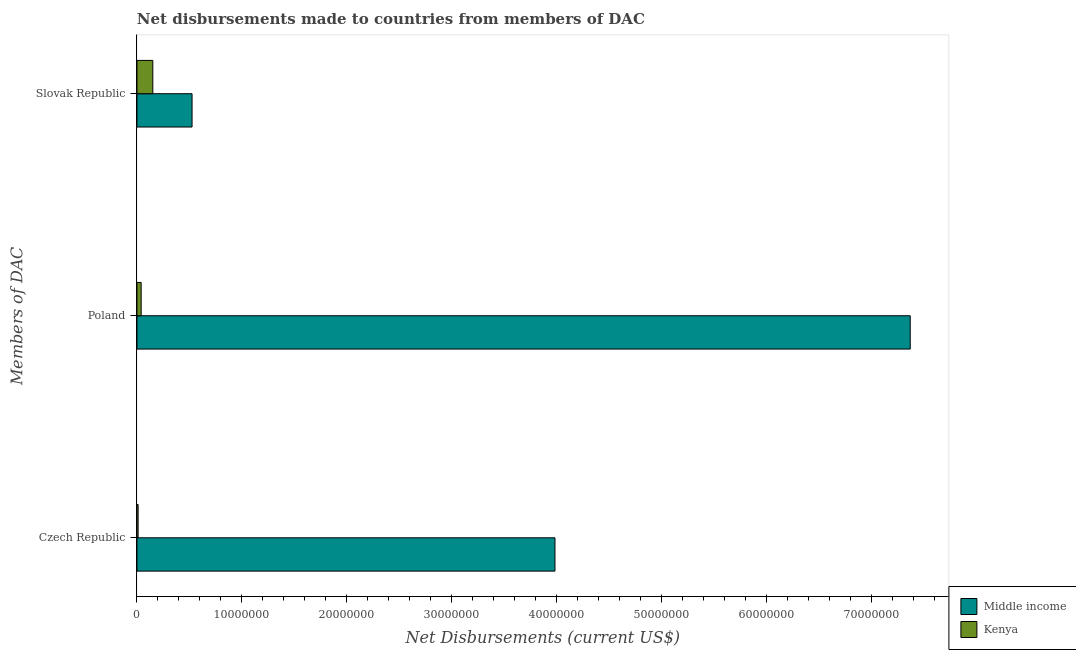Are the number of bars on each tick of the Y-axis equal?
Your answer should be compact. Yes. How many bars are there on the 2nd tick from the bottom?
Make the answer very short. 2. What is the net disbursements made by czech republic in Kenya?
Offer a terse response. 1.10e+05. Across all countries, what is the maximum net disbursements made by poland?
Your response must be concise. 7.37e+07. Across all countries, what is the minimum net disbursements made by slovak republic?
Provide a short and direct response. 1.51e+06. In which country was the net disbursements made by slovak republic minimum?
Offer a terse response. Kenya. What is the total net disbursements made by poland in the graph?
Your answer should be very brief. 7.41e+07. What is the difference between the net disbursements made by czech republic in Middle income and that in Kenya?
Keep it short and to the point. 3.97e+07. What is the difference between the net disbursements made by slovak republic in Middle income and the net disbursements made by czech republic in Kenya?
Make the answer very short. 5.14e+06. What is the average net disbursements made by czech republic per country?
Give a very brief answer. 2.00e+07. What is the difference between the net disbursements made by czech republic and net disbursements made by slovak republic in Middle income?
Offer a terse response. 3.46e+07. In how many countries, is the net disbursements made by poland greater than 30000000 US$?
Keep it short and to the point. 1. What is the ratio of the net disbursements made by poland in Middle income to that in Kenya?
Offer a terse response. 184.2. What is the difference between the highest and the second highest net disbursements made by poland?
Offer a terse response. 7.33e+07. What is the difference between the highest and the lowest net disbursements made by czech republic?
Ensure brevity in your answer.  3.97e+07. What does the 1st bar from the top in Poland represents?
Provide a succinct answer. Kenya. What does the 2nd bar from the bottom in Poland represents?
Your answer should be very brief. Kenya. How many bars are there?
Give a very brief answer. 6. Are all the bars in the graph horizontal?
Provide a short and direct response. Yes. How many countries are there in the graph?
Your response must be concise. 2. What is the difference between two consecutive major ticks on the X-axis?
Your response must be concise. 1.00e+07. Are the values on the major ticks of X-axis written in scientific E-notation?
Provide a short and direct response. No. Does the graph contain any zero values?
Ensure brevity in your answer.  No. Does the graph contain grids?
Make the answer very short. No. Where does the legend appear in the graph?
Ensure brevity in your answer.  Bottom right. What is the title of the graph?
Offer a terse response. Net disbursements made to countries from members of DAC. Does "Venezuela" appear as one of the legend labels in the graph?
Make the answer very short. No. What is the label or title of the X-axis?
Provide a short and direct response. Net Disbursements (current US$). What is the label or title of the Y-axis?
Make the answer very short. Members of DAC. What is the Net Disbursements (current US$) of Middle income in Czech Republic?
Your answer should be very brief. 3.98e+07. What is the Net Disbursements (current US$) in Middle income in Poland?
Your answer should be very brief. 7.37e+07. What is the Net Disbursements (current US$) of Kenya in Poland?
Make the answer very short. 4.00e+05. What is the Net Disbursements (current US$) of Middle income in Slovak Republic?
Make the answer very short. 5.25e+06. What is the Net Disbursements (current US$) of Kenya in Slovak Republic?
Keep it short and to the point. 1.51e+06. Across all Members of DAC, what is the maximum Net Disbursements (current US$) in Middle income?
Offer a terse response. 7.37e+07. Across all Members of DAC, what is the maximum Net Disbursements (current US$) of Kenya?
Your answer should be compact. 1.51e+06. Across all Members of DAC, what is the minimum Net Disbursements (current US$) of Middle income?
Your answer should be compact. 5.25e+06. Across all Members of DAC, what is the minimum Net Disbursements (current US$) in Kenya?
Ensure brevity in your answer.  1.10e+05. What is the total Net Disbursements (current US$) in Middle income in the graph?
Offer a terse response. 1.19e+08. What is the total Net Disbursements (current US$) in Kenya in the graph?
Provide a short and direct response. 2.02e+06. What is the difference between the Net Disbursements (current US$) in Middle income in Czech Republic and that in Poland?
Provide a short and direct response. -3.38e+07. What is the difference between the Net Disbursements (current US$) of Middle income in Czech Republic and that in Slovak Republic?
Make the answer very short. 3.46e+07. What is the difference between the Net Disbursements (current US$) in Kenya in Czech Republic and that in Slovak Republic?
Provide a succinct answer. -1.40e+06. What is the difference between the Net Disbursements (current US$) in Middle income in Poland and that in Slovak Republic?
Your response must be concise. 6.84e+07. What is the difference between the Net Disbursements (current US$) of Kenya in Poland and that in Slovak Republic?
Give a very brief answer. -1.11e+06. What is the difference between the Net Disbursements (current US$) of Middle income in Czech Republic and the Net Disbursements (current US$) of Kenya in Poland?
Your answer should be very brief. 3.94e+07. What is the difference between the Net Disbursements (current US$) of Middle income in Czech Republic and the Net Disbursements (current US$) of Kenya in Slovak Republic?
Ensure brevity in your answer.  3.83e+07. What is the difference between the Net Disbursements (current US$) of Middle income in Poland and the Net Disbursements (current US$) of Kenya in Slovak Republic?
Make the answer very short. 7.22e+07. What is the average Net Disbursements (current US$) of Middle income per Members of DAC?
Keep it short and to the point. 3.96e+07. What is the average Net Disbursements (current US$) in Kenya per Members of DAC?
Ensure brevity in your answer.  6.73e+05. What is the difference between the Net Disbursements (current US$) of Middle income and Net Disbursements (current US$) of Kenya in Czech Republic?
Ensure brevity in your answer.  3.97e+07. What is the difference between the Net Disbursements (current US$) of Middle income and Net Disbursements (current US$) of Kenya in Poland?
Make the answer very short. 7.33e+07. What is the difference between the Net Disbursements (current US$) in Middle income and Net Disbursements (current US$) in Kenya in Slovak Republic?
Provide a short and direct response. 3.74e+06. What is the ratio of the Net Disbursements (current US$) of Middle income in Czech Republic to that in Poland?
Give a very brief answer. 0.54. What is the ratio of the Net Disbursements (current US$) in Kenya in Czech Republic to that in Poland?
Provide a short and direct response. 0.28. What is the ratio of the Net Disbursements (current US$) in Middle income in Czech Republic to that in Slovak Republic?
Keep it short and to the point. 7.59. What is the ratio of the Net Disbursements (current US$) of Kenya in Czech Republic to that in Slovak Republic?
Ensure brevity in your answer.  0.07. What is the ratio of the Net Disbursements (current US$) of Middle income in Poland to that in Slovak Republic?
Your response must be concise. 14.03. What is the ratio of the Net Disbursements (current US$) in Kenya in Poland to that in Slovak Republic?
Your answer should be compact. 0.26. What is the difference between the highest and the second highest Net Disbursements (current US$) in Middle income?
Offer a very short reply. 3.38e+07. What is the difference between the highest and the second highest Net Disbursements (current US$) in Kenya?
Provide a short and direct response. 1.11e+06. What is the difference between the highest and the lowest Net Disbursements (current US$) of Middle income?
Your answer should be very brief. 6.84e+07. What is the difference between the highest and the lowest Net Disbursements (current US$) of Kenya?
Your answer should be very brief. 1.40e+06. 